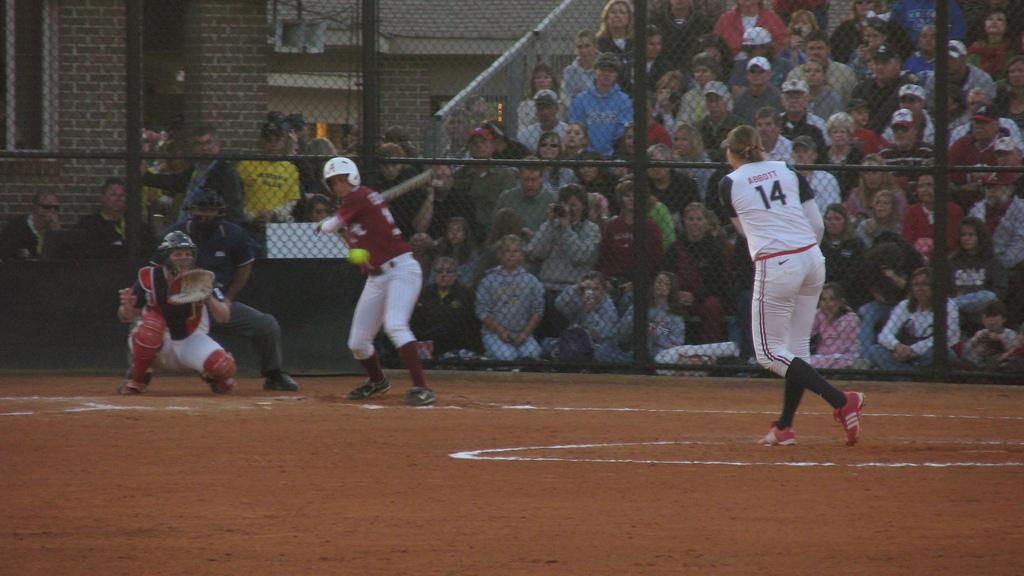<image>
Share a concise interpretation of the image provided. The pitcher, who is number 14, has just thrown the ball to the batter. 